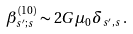<formula> <loc_0><loc_0><loc_500><loc_500>\beta ^ { ( 1 0 ) } _ { s ^ { \prime } ; s } \sim 2 G \mu _ { 0 } \delta _ { s ^ { \prime } , s } \, .</formula> 